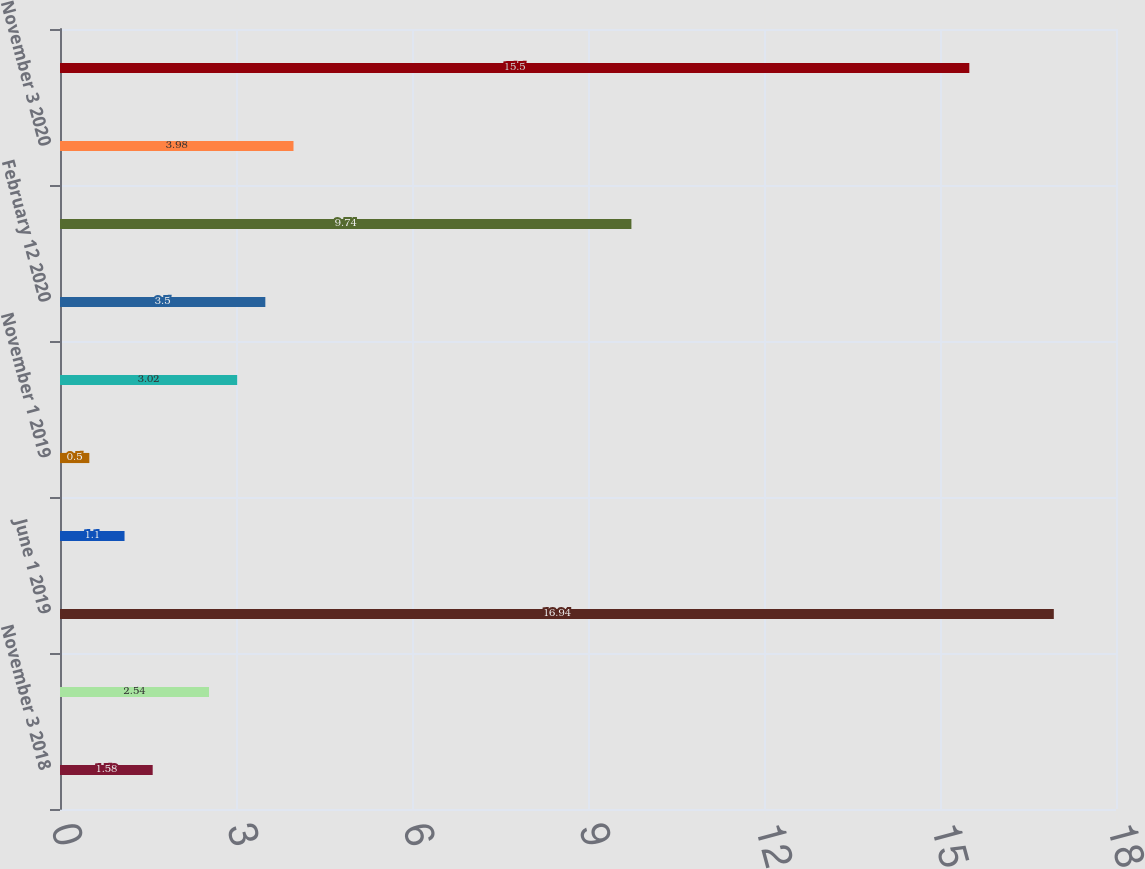Convert chart to OTSL. <chart><loc_0><loc_0><loc_500><loc_500><bar_chart><fcel>November 3 2018<fcel>December 6 2018<fcel>June 1 2019<fcel>August 8 2019<fcel>November 1 2019<fcel>February 6 2020<fcel>February 12 2020<fcel>October 1 2020<fcel>November 3 2020<fcel>February 8 2021<nl><fcel>1.58<fcel>2.54<fcel>16.94<fcel>1.1<fcel>0.5<fcel>3.02<fcel>3.5<fcel>9.74<fcel>3.98<fcel>15.5<nl></chart> 